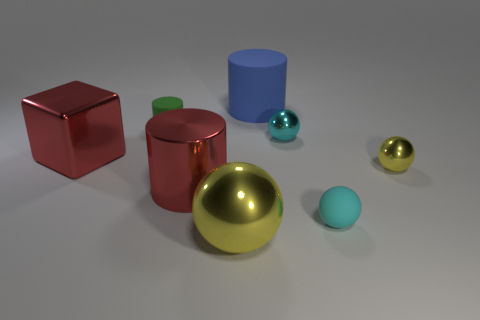Add 1 large metallic cylinders. How many objects exist? 9 Subtract all cylinders. How many objects are left? 5 Subtract 1 yellow spheres. How many objects are left? 7 Subtract all green rubber things. Subtract all big metallic objects. How many objects are left? 4 Add 3 cyan objects. How many cyan objects are left? 5 Add 6 metallic blocks. How many metallic blocks exist? 7 